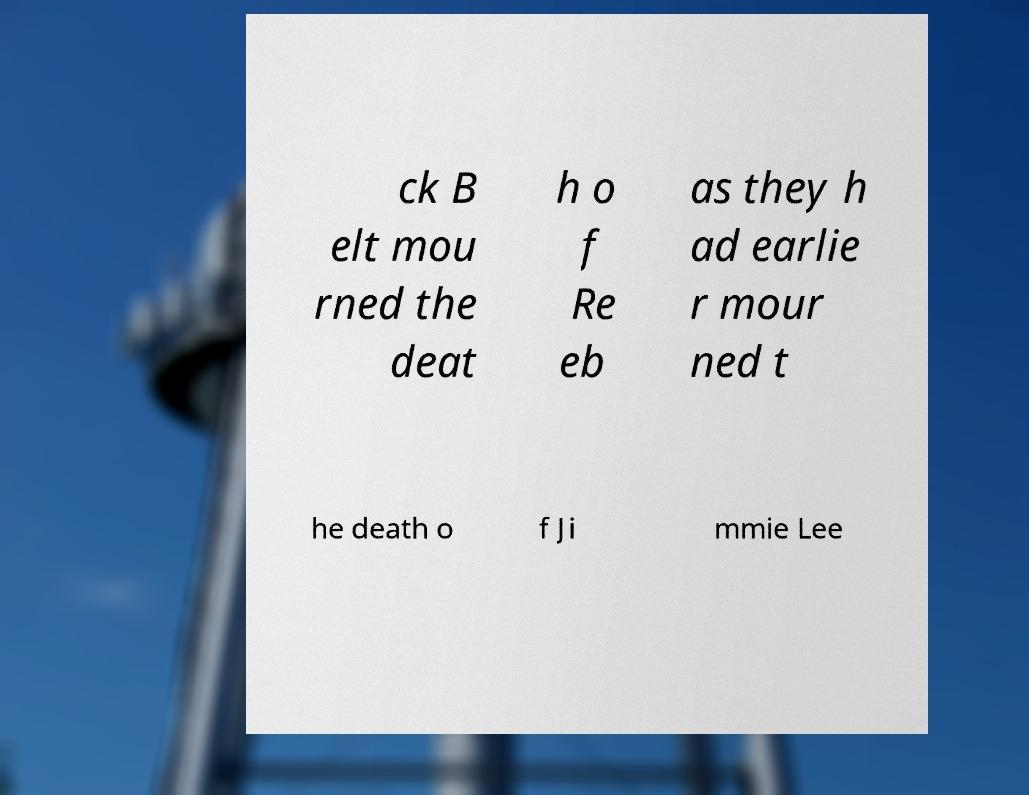I need the written content from this picture converted into text. Can you do that? ck B elt mou rned the deat h o f Re eb as they h ad earlie r mour ned t he death o f Ji mmie Lee 